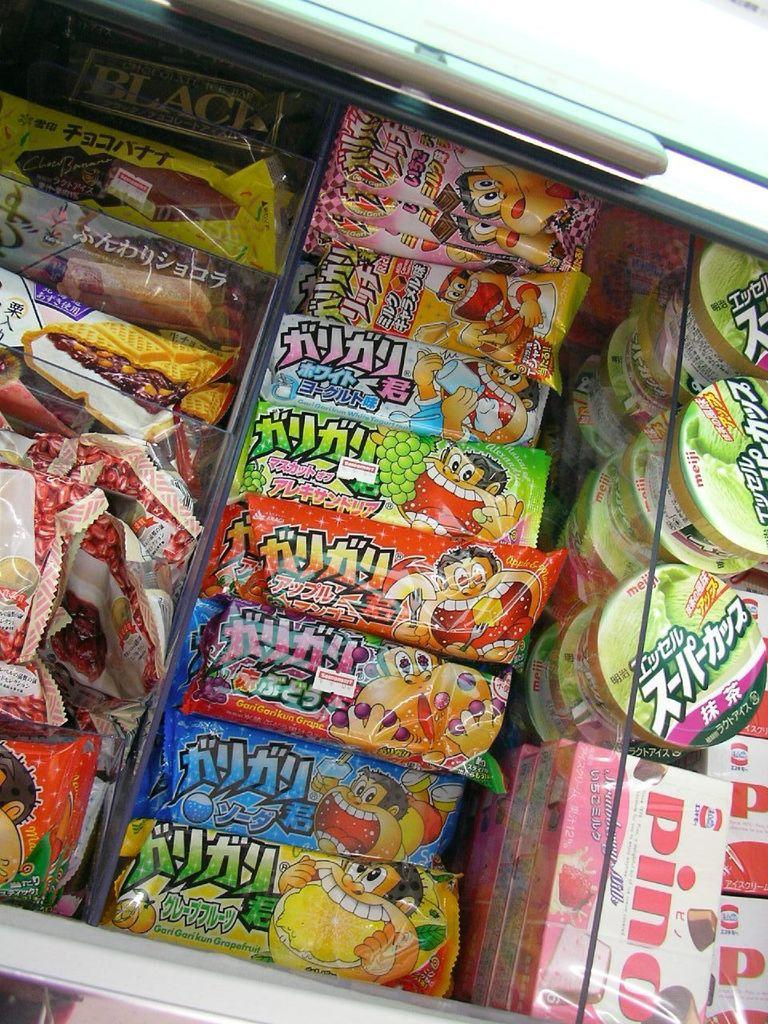Provide a one-sentence caption for the provided image. A case of asian treats including some Pinos. 